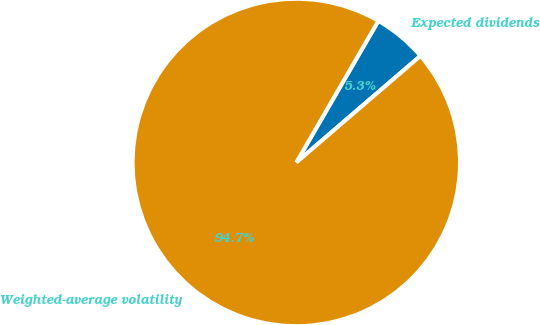Convert chart to OTSL. <chart><loc_0><loc_0><loc_500><loc_500><pie_chart><fcel>Expected dividends<fcel>Weighted-average volatility<nl><fcel>5.35%<fcel>94.65%<nl></chart> 